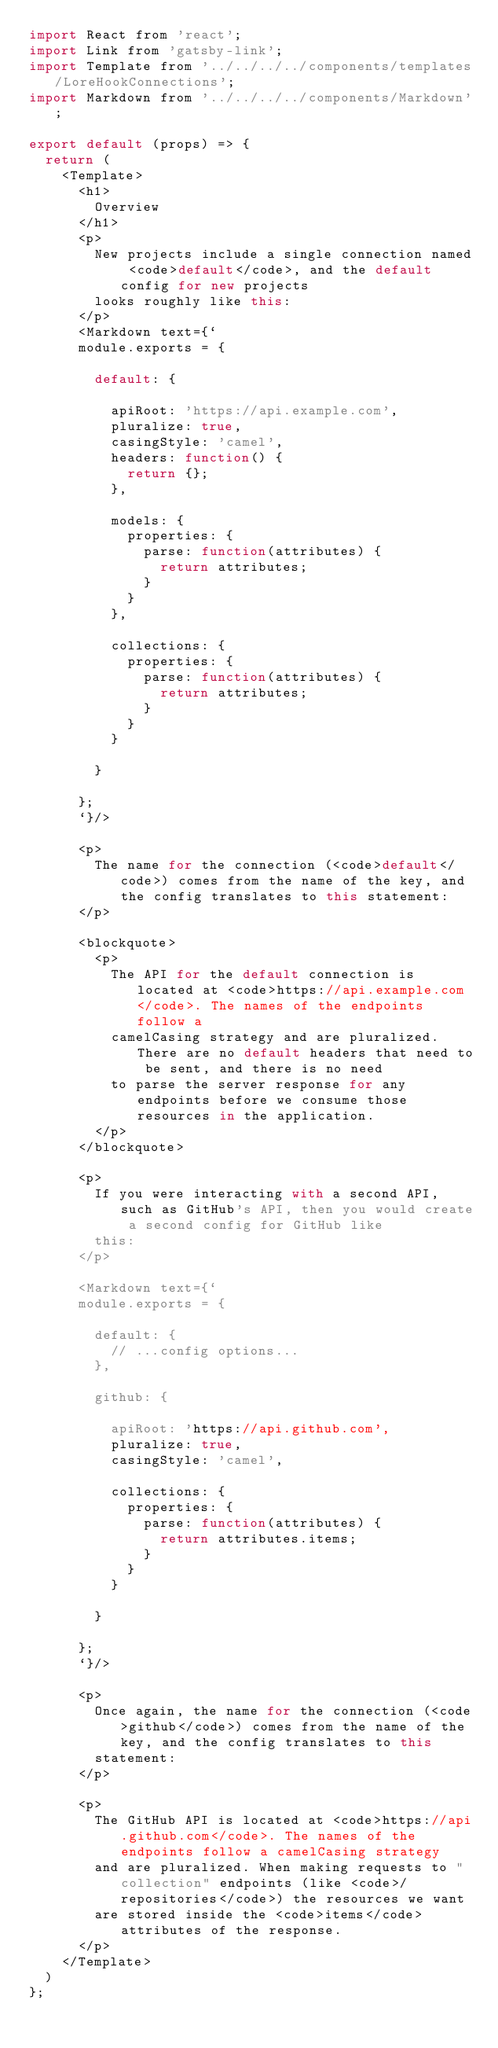<code> <loc_0><loc_0><loc_500><loc_500><_JavaScript_>import React from 'react';
import Link from 'gatsby-link';
import Template from '../../../../components/templates/LoreHookConnections';
import Markdown from '../../../../components/Markdown';

export default (props) => {
  return (
    <Template>
      <h1>
        Overview
      </h1>
      <p>
        New projects include a single connection named <code>default</code>, and the default config for new projects
        looks roughly like this:
      </p>
      <Markdown text={`
      module.exports = {

        default: {

          apiRoot: 'https://api.example.com',
          pluralize: true,
          casingStyle: 'camel',
          headers: function() {
            return {};
          },

          models: {
            properties: {
              parse: function(attributes) {
                return attributes;
              }
            }
          },

          collections: {
            properties: {
              parse: function(attributes) {
                return attributes;
              }
            }
          }

        }

      };
      `}/>

      <p>
        The name for the connection (<code>default</code>) comes from the name of the key, and the config translates to this statement:
      </p>

      <blockquote>
        <p>
          The API for the default connection is located at <code>https://api.example.com</code>. The names of the endpoints follow a
          camelCasing strategy and are pluralized. There are no default headers that need to be sent, and there is no need
          to parse the server response for any endpoints before we consume those resources in the application.
        </p>
      </blockquote>

      <p>
        If you were interacting with a second API, such as GitHub's API, then you would create a second config for GitHub like
        this:
      </p>

      <Markdown text={`
      module.exports = {

        default: {
          // ...config options...
        },

        github: {

          apiRoot: 'https://api.github.com',
          pluralize: true,
          casingStyle: 'camel',

          collections: {
            properties: {
              parse: function(attributes) {
                return attributes.items;
              }
            }
          }

        }

      };
      `}/>

      <p>
        Once again, the name for the connection (<code>github</code>) comes from the name of the key, and the config translates to this
        statement:
      </p>

      <p>
        The GitHub API is located at <code>https://api.github.com</code>. The names of the endpoints follow a camelCasing strategy
        and are pluralized. When making requests to "collection" endpoints (like <code>/repositories</code>) the resources we want
        are stored inside the <code>items</code> attributes of the response.
      </p>
    </Template>
  )
};
</code> 